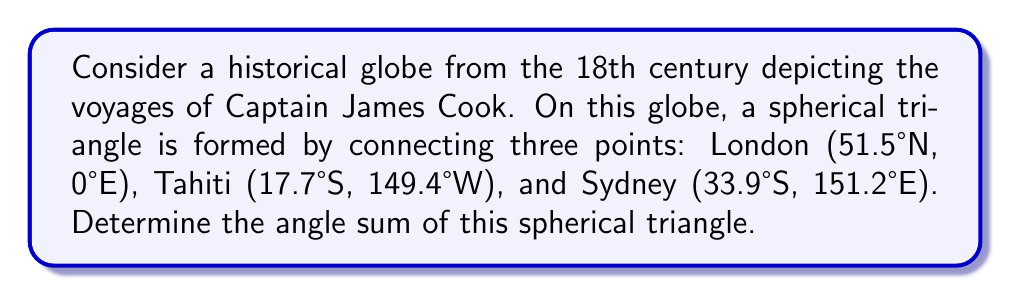What is the answer to this math problem? To solve this problem, we'll follow these steps:

1) Recall the formula for the angle sum of a spherical triangle:
   $$A + B + C = 180° + E$$
   where $A$, $B$, and $C$ are the angles of the triangle, and $E$ is the spherical excess.

2) The spherical excess $E$ is related to the area of the triangle and the radius of the sphere:
   $$E = \frac{Area}{R^2}$$
   where $Area$ is in steradians and $R$ is the radius of the sphere.

3) For a unit sphere (radius = 1), the area of a spherical triangle is given by:
   $$Area = A + B + C - \pi$$
   where angles are in radians.

4) Combining steps 1 and 3:
   $$A + B + C = 180° + (A + B + C - \pi)$$
   $$\pi = 180°$$
   $$A + B + C = 180° + 180° = 360°$$

5) This result is independent of the specific locations chosen on the globe, as long as they form a spherical triangle.

Therefore, the angle sum of the spherical triangle on the historical globe is always 360°, regardless of the specific locations of London, Tahiti, and Sydney.
Answer: 360° 